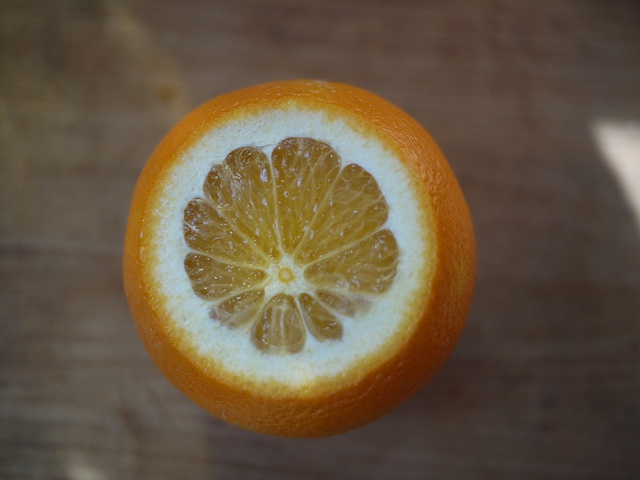Describe the objects in this image and their specific colors. I can see a orange in black, olive, and darkgray tones in this image. 